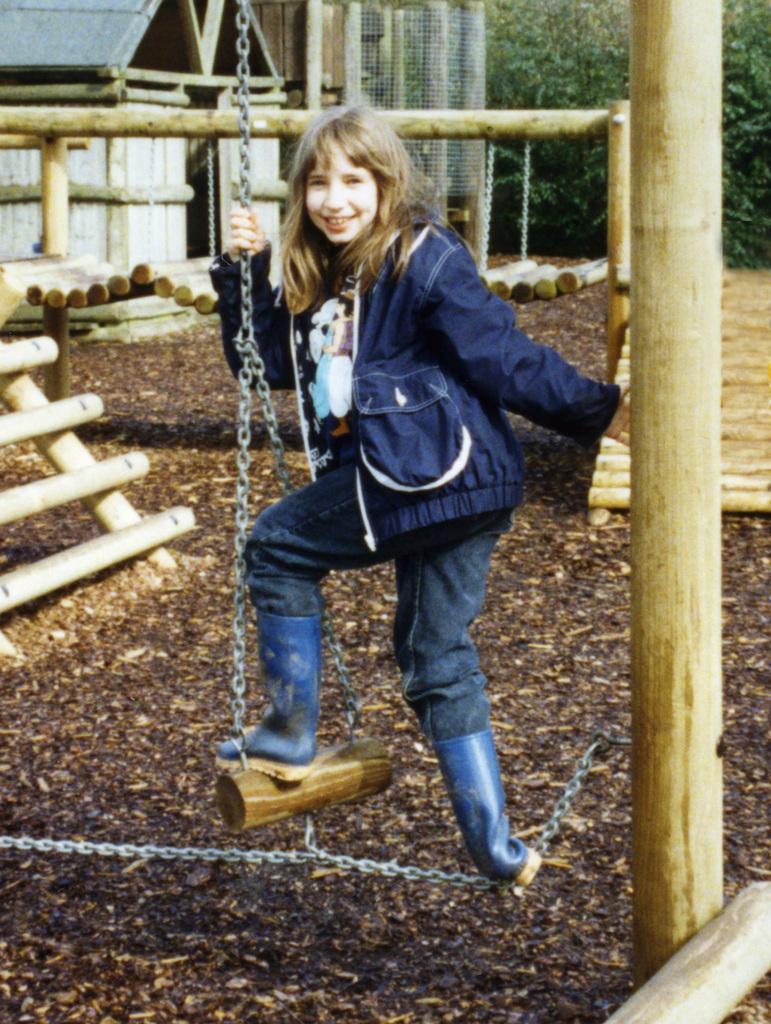Could you give a brief overview of what you see in this image? In this image I can see the person holding the chain of the swing. The person is wearing the blue color dress. To the side of the person I can see the many wooden objects. In the background I can see the house and many trees. 